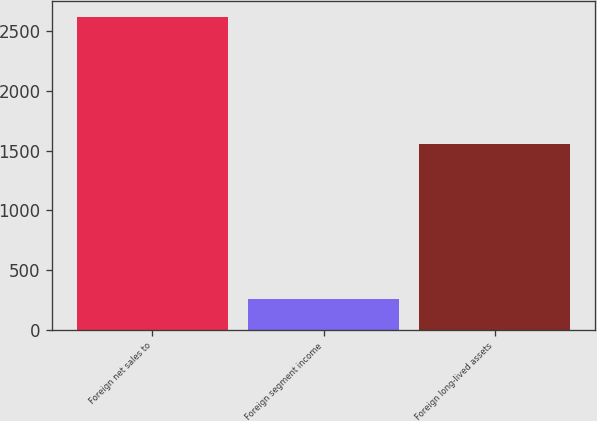Convert chart. <chart><loc_0><loc_0><loc_500><loc_500><bar_chart><fcel>Foreign net sales to<fcel>Foreign segment income<fcel>Foreign long-lived assets<nl><fcel>2621.2<fcel>260.1<fcel>1558.3<nl></chart> 